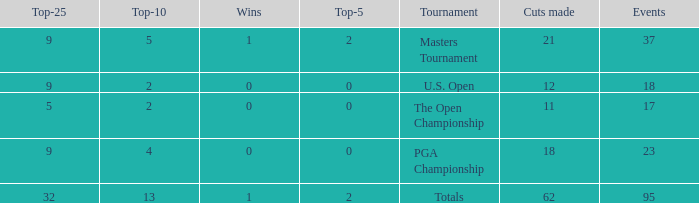What is the lowest top 5 winners with less than 0? None. 